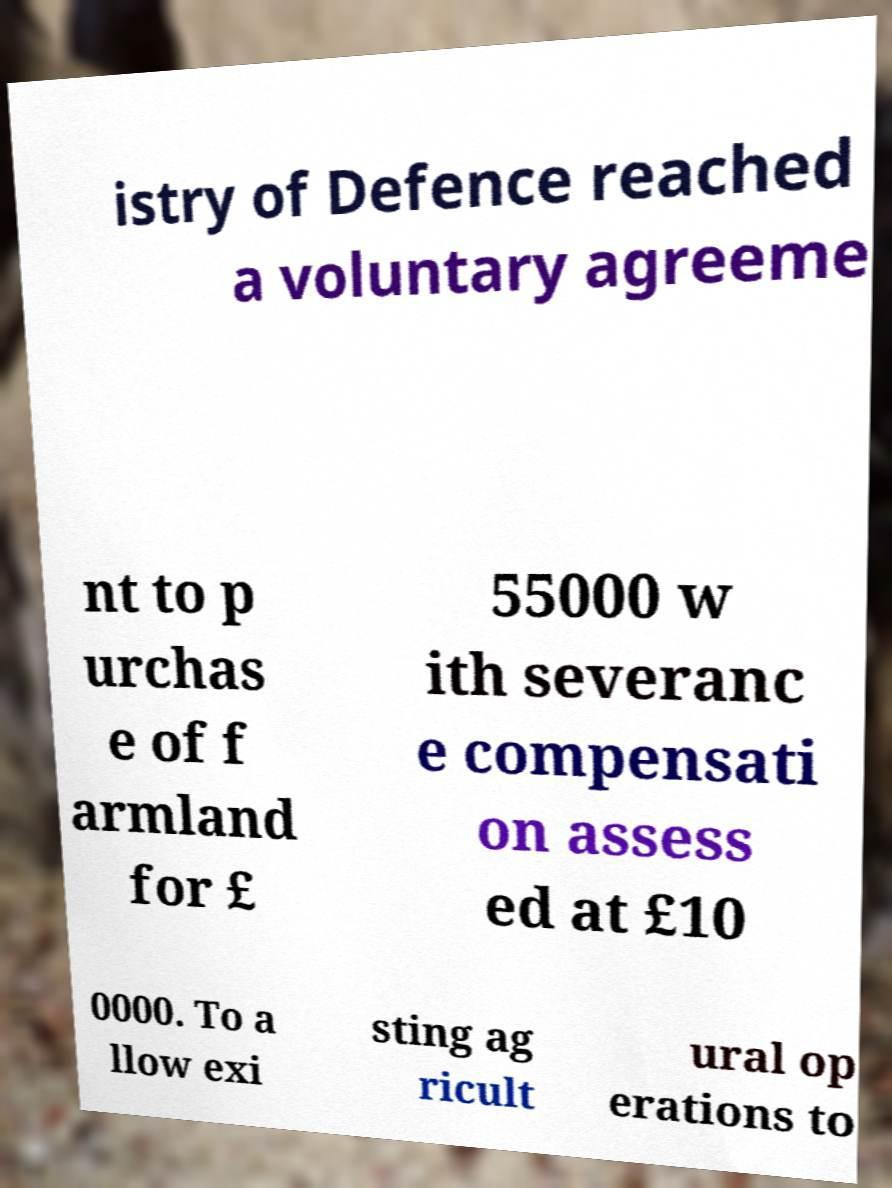Please read and relay the text visible in this image. What does it say? istry of Defence reached a voluntary agreeme nt to p urchas e of f armland for £ 55000 w ith severanc e compensati on assess ed at £10 0000. To a llow exi sting ag ricult ural op erations to 